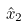Convert formula to latex. <formula><loc_0><loc_0><loc_500><loc_500>\hat { x } _ { 2 }</formula> 